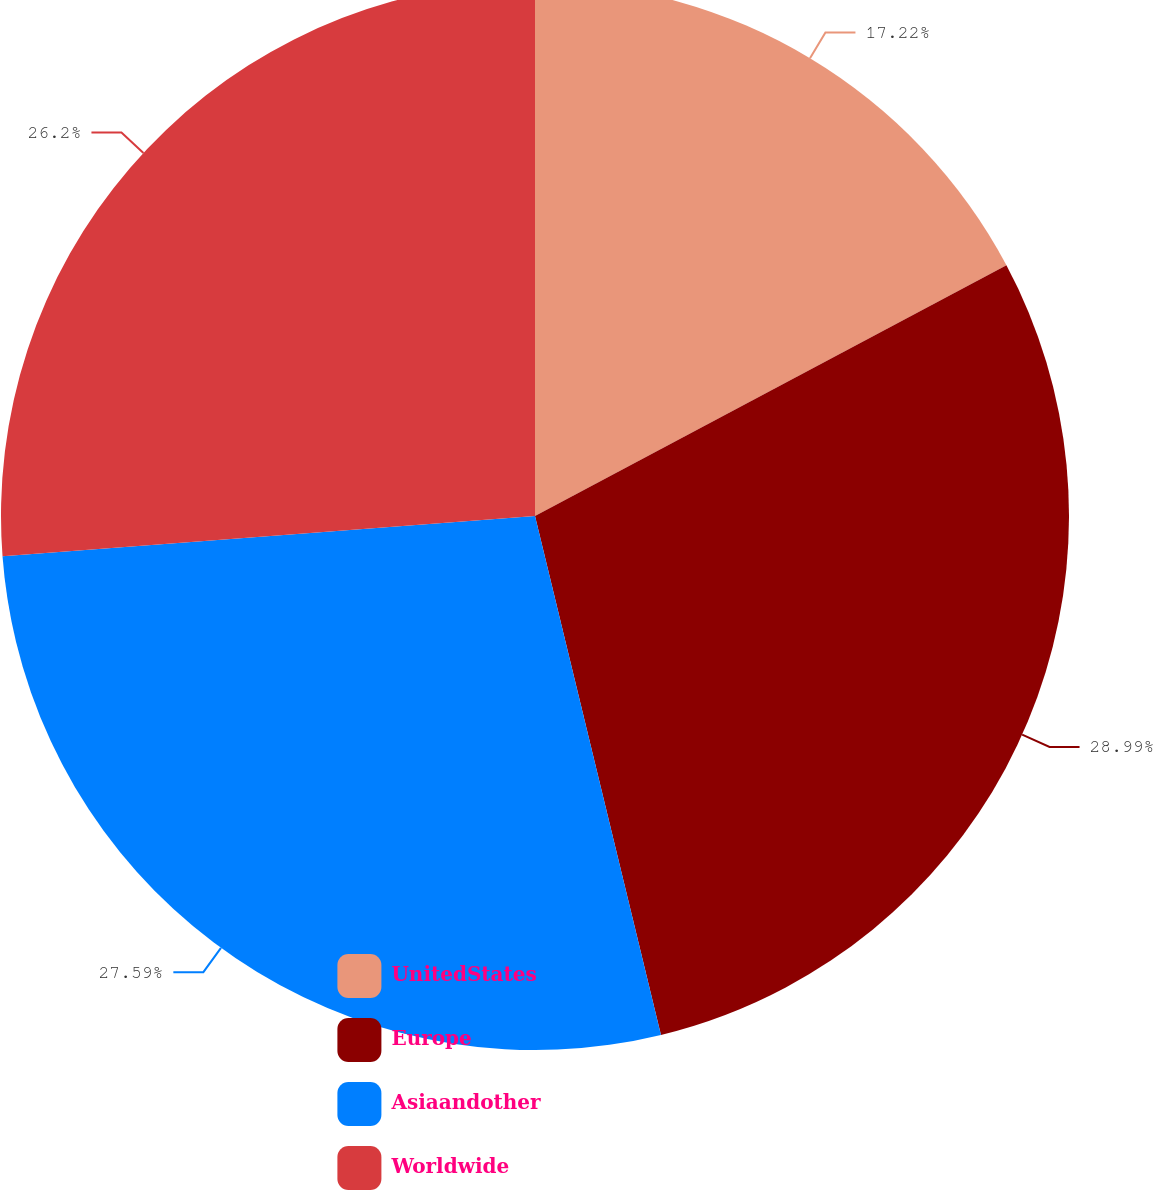Convert chart to OTSL. <chart><loc_0><loc_0><loc_500><loc_500><pie_chart><fcel>UnitedStates<fcel>Europe<fcel>Asiaandother<fcel>Worldwide<nl><fcel>17.22%<fcel>28.99%<fcel>27.59%<fcel>26.2%<nl></chart> 